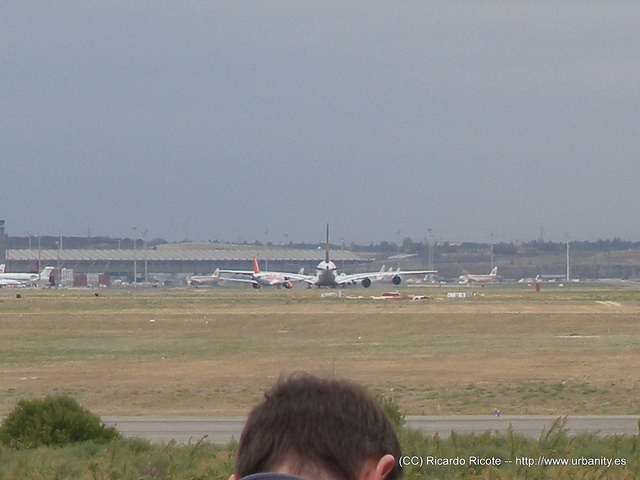Describe the objects in this image and their specific colors. I can see people in darkgray, black, and gray tones, airplane in darkgray, gray, and lightgray tones, airplane in darkgray, lightgray, and gray tones, airplane in darkgray, lightgray, and gray tones, and airplane in darkgray, lightgray, and gray tones in this image. 